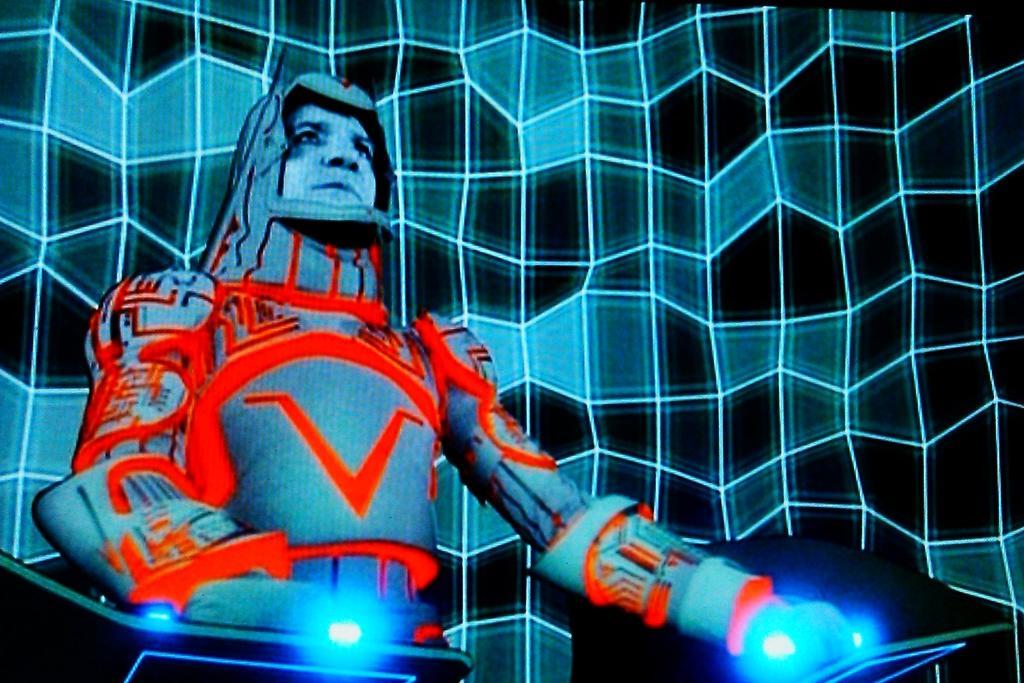What type of image is depicted in the picture? The image is an animated image of a person standing. What is the person wearing in the image? The person is wearing a costume in the image. Can you describe the lighting in the image? There are lights visible in the image. How would you describe the background of the image? The background is pale blue and dark in color. How many rabbits are visible in the image? There are no rabbits present in the image; it is an animated image of a person standing. What type of glue is being used to attach the costume to the person in the image? There is no indication of glue or any adhesive being used in the image; the costume is simply worn by the person. 